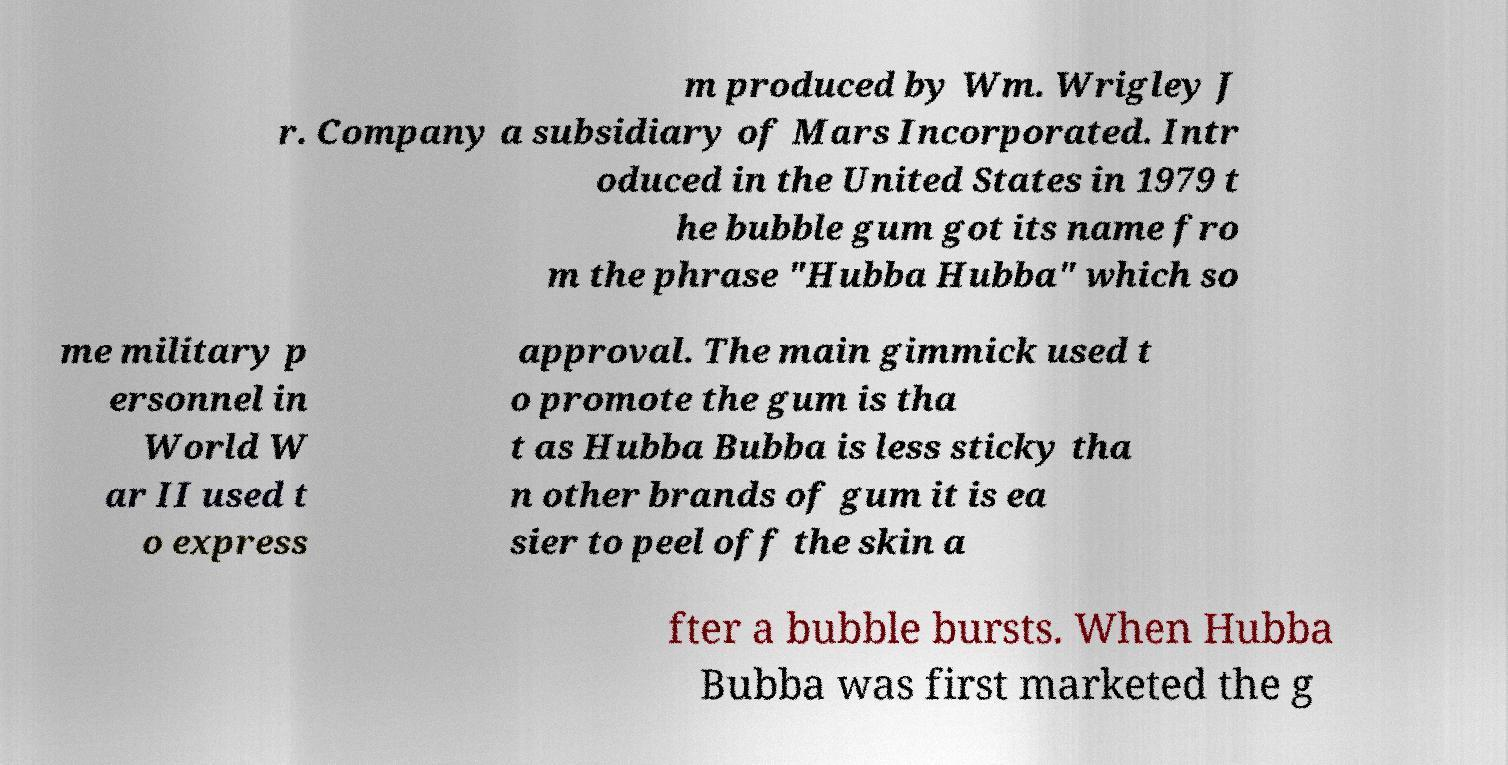For documentation purposes, I need the text within this image transcribed. Could you provide that? m produced by Wm. Wrigley J r. Company a subsidiary of Mars Incorporated. Intr oduced in the United States in 1979 t he bubble gum got its name fro m the phrase "Hubba Hubba" which so me military p ersonnel in World W ar II used t o express approval. The main gimmick used t o promote the gum is tha t as Hubba Bubba is less sticky tha n other brands of gum it is ea sier to peel off the skin a fter a bubble bursts. When Hubba Bubba was first marketed the g 